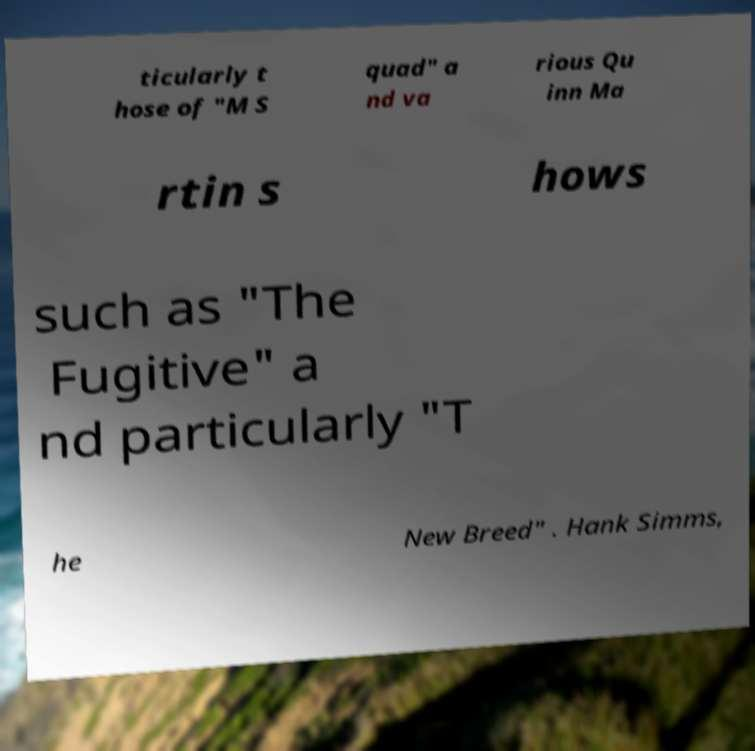Could you extract and type out the text from this image? ticularly t hose of "M S quad" a nd va rious Qu inn Ma rtin s hows such as "The Fugitive" a nd particularly "T he New Breed" . Hank Simms, 